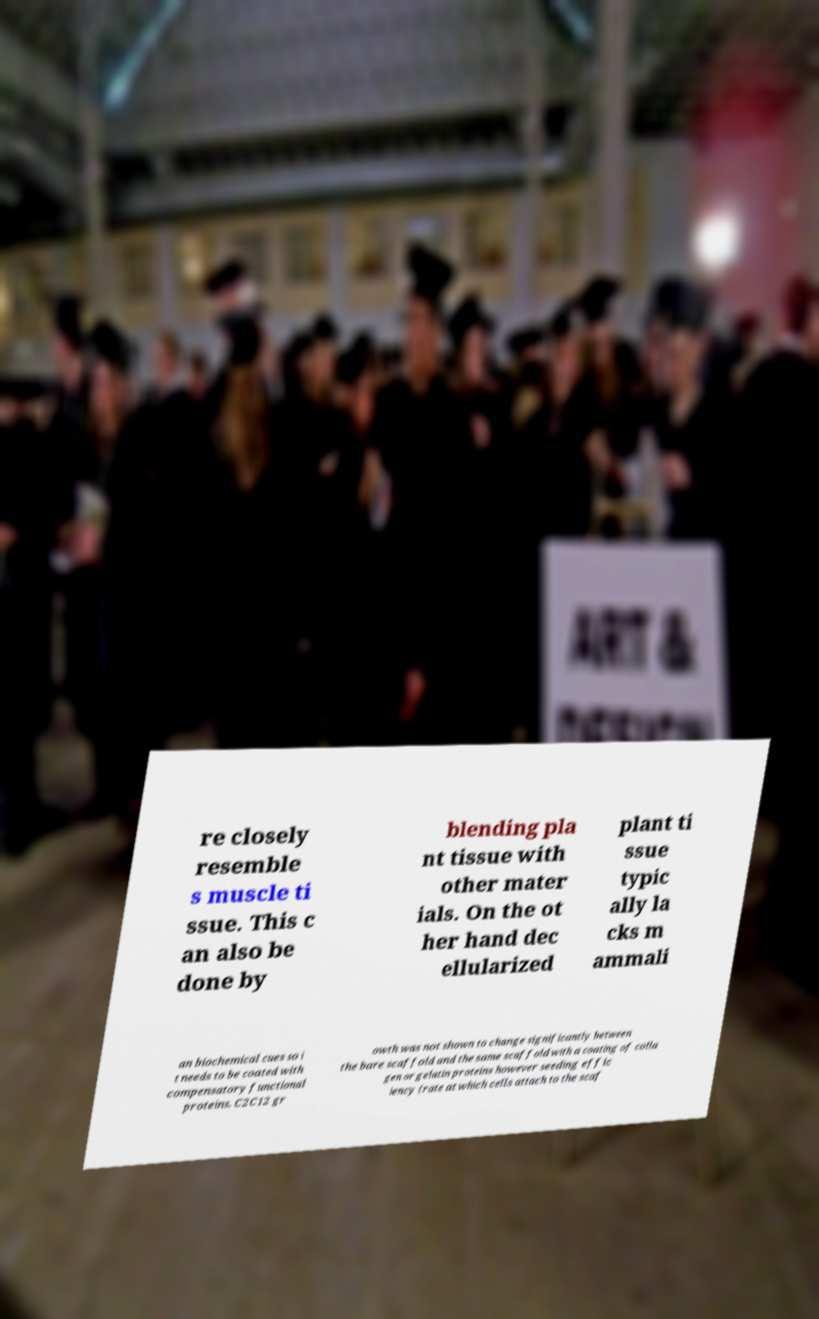Could you extract and type out the text from this image? re closely resemble s muscle ti ssue. This c an also be done by blending pla nt tissue with other mater ials. On the ot her hand dec ellularized plant ti ssue typic ally la cks m ammali an biochemical cues so i t needs to be coated with compensatory functional proteins. C2C12 gr owth was not shown to change significantly between the bare scaffold and the same scaffold with a coating of colla gen or gelatin proteins however seeding effic iency (rate at which cells attach to the scaf 